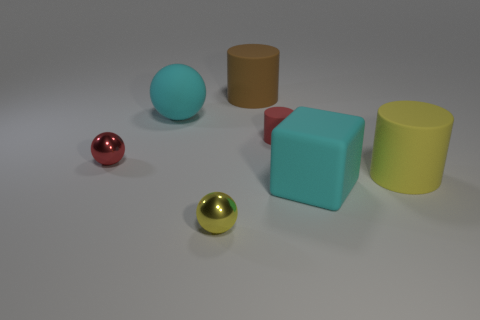Are there the same number of yellow cylinders that are to the left of the red shiny sphere and tiny cyan metallic things?
Provide a succinct answer. Yes. Are there any matte cubes left of the block?
Your answer should be very brief. No. What is the size of the red rubber thing behind the shiny thing that is to the right of the tiny shiny thing behind the yellow rubber object?
Make the answer very short. Small. There is a cyan thing behind the large cyan block; is it the same shape as the cyan matte object that is in front of the red rubber cylinder?
Your answer should be very brief. No. What size is the red thing that is the same shape as the brown thing?
Offer a terse response. Small. What number of big gray blocks have the same material as the big cyan block?
Ensure brevity in your answer.  0. What is the big cyan cube made of?
Provide a succinct answer. Rubber. The small thing behind the tiny sphere on the left side of the yellow ball is what shape?
Your answer should be very brief. Cylinder. What is the shape of the big cyan object that is on the left side of the brown rubber cylinder?
Your response must be concise. Sphere. How many large things are the same color as the cube?
Ensure brevity in your answer.  1. 